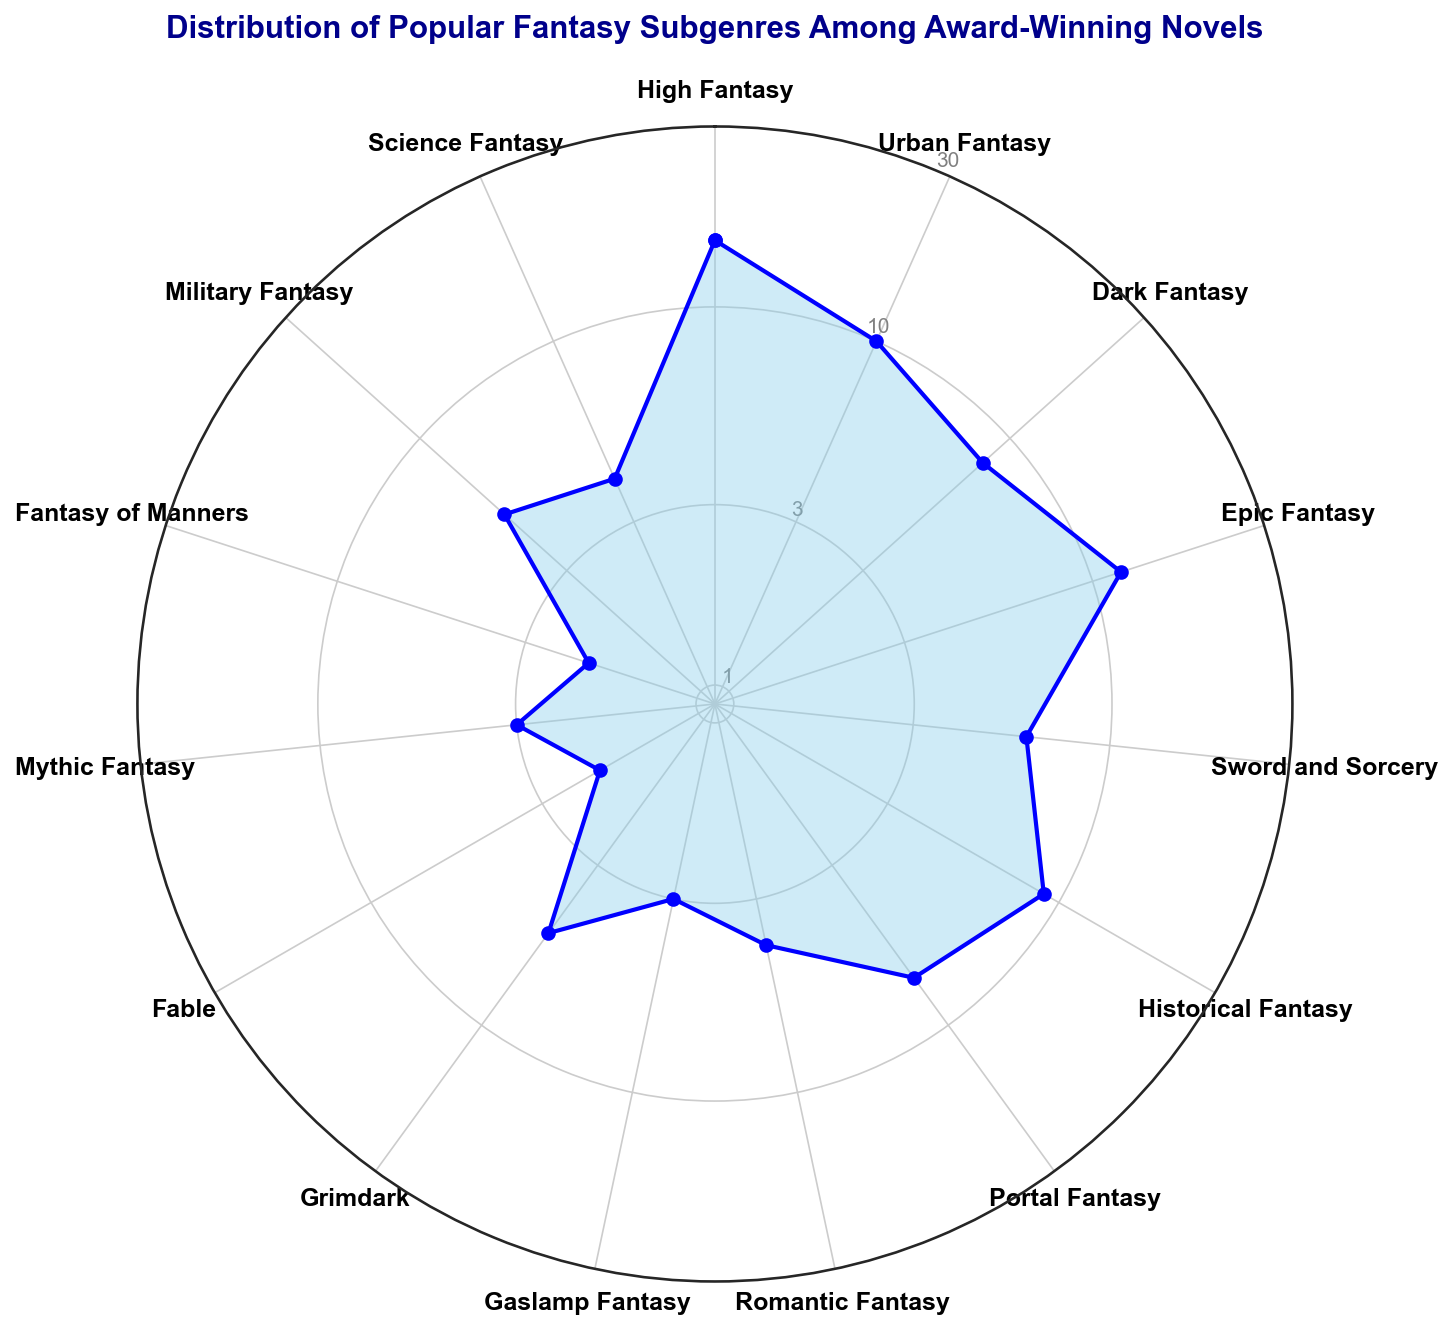Which subgenre has the highest number of award-winning novels? The subgenre with the highest number of award-winning novels will have the largest value point on the plot. In this case, it is "High Fantasy" with a value of 15.
Answer: High Fantasy Which subgenre has twice as many award-winning novels as Gaslamp Fantasy? From the plot, Gaslamp Fantasy has 3 award-winning novels. A subgenre that has twice as many would have 6. "Sword and Sorcery" meets this criterion.
Answer: Sword and Sorcery How many subgenres have fewer than 5 award-winning novels? Identify all subgenres with values below 5 on the plot. These include: Romantic Fantasy, Gaslamp Fantasy, Fable, and Fantasy of Manners, making it a total of 4.
Answer: 4 What is the difference in the number of award-winning novels between Epic Fantasy and Dark Fantasy? From the plot, Epic Fantasy has 12 and Dark Fantasy has 8. The difference between these is 12 - 8 = 4.
Answer: 4 Is the number of award-winning novels for Urban Fantasy greater than for Military Fantasy? Urban Fantasy has 10 award-winning novels, while Military Fantasy has 5. Since 10 is greater than 5, the answer is yes.
Answer: Yes What is the combined total number of award-winning novels for High Fantasy and Romantic Fantasy? High Fantasy has 15, and Romantic Fantasy has 4. Their combined total is 15 + 4 = 19.
Answer: 19 Which subgenre has the least number of award-winning novels? The subgenre with the smallest value on the plot is "Fable" with 2 award-winning novels.
Answer: Fable Are there more award-winning novels in High Fantasy than the sum of Science Fantasy and Mythic Fantasy? High Fantasy has 15 novels. Science Fantasy has 4 and Mythic Fantasy has 3. The sum of Science Fantasy and Mythic Fantasy is 4 + 3 = 7, which is less than 15.
Answer: Yes What is the median number of award-winning novels among all subgenres? List all numbers: 15, 10, 8, 12, 6, 9, 7, 4, 3, 5, 2, 3, 2, 5, 4. When ordered: 2, 2, 3, 3, 4, 4, 5, 5, 6, 7, 8, 9, 10, 12, 15. The median (8th value) is 5.
Answer: 5 Which two subgenres have a combined total exactly equal to the number for Epic Fantasy? Epic Fantasy has 12 novels. Dark Fantasy has 8 and Gaslamp Fantasy has 3, with a combined total of 8 + 4 != 12. Next, consider Dark Fantasy and Sword and Sorcery: 8 + 6 != 12. Check Historical Fantasy and Sword and Sorcery: 9 + 3 also does not match. Upon checking Urban Fantasy and Science Fantasy: 10 + 2 = 12. Therefore, Urban Fantasy and Science Fantasy combined result in 12.
Answer: Urban Fantasy and Science Fantasy 